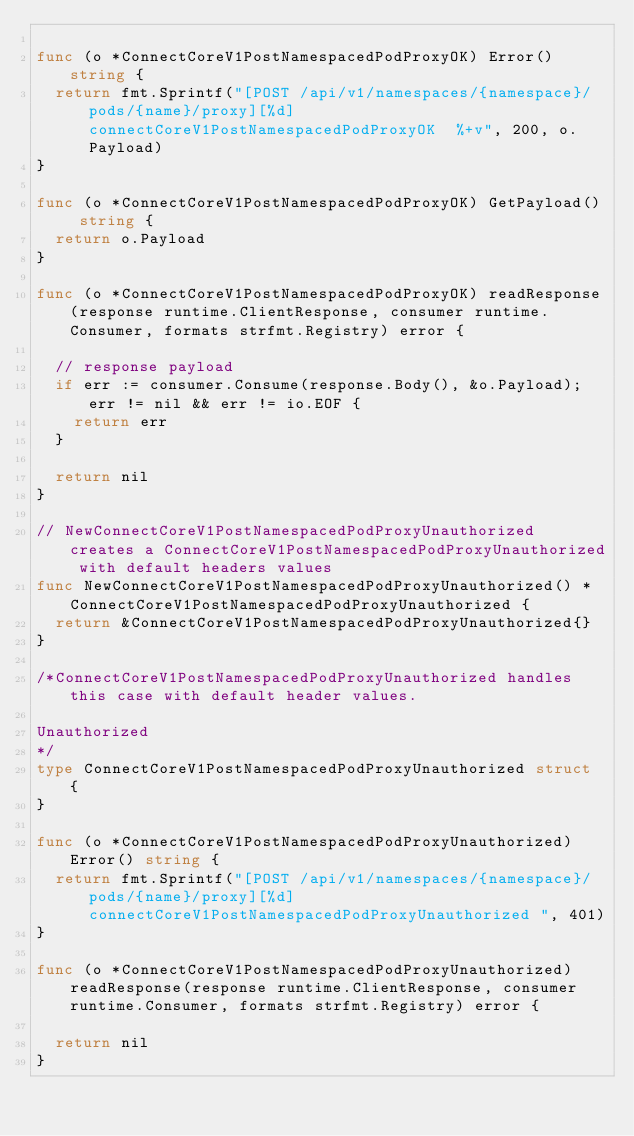<code> <loc_0><loc_0><loc_500><loc_500><_Go_>
func (o *ConnectCoreV1PostNamespacedPodProxyOK) Error() string {
	return fmt.Sprintf("[POST /api/v1/namespaces/{namespace}/pods/{name}/proxy][%d] connectCoreV1PostNamespacedPodProxyOK  %+v", 200, o.Payload)
}

func (o *ConnectCoreV1PostNamespacedPodProxyOK) GetPayload() string {
	return o.Payload
}

func (o *ConnectCoreV1PostNamespacedPodProxyOK) readResponse(response runtime.ClientResponse, consumer runtime.Consumer, formats strfmt.Registry) error {

	// response payload
	if err := consumer.Consume(response.Body(), &o.Payload); err != nil && err != io.EOF {
		return err
	}

	return nil
}

// NewConnectCoreV1PostNamespacedPodProxyUnauthorized creates a ConnectCoreV1PostNamespacedPodProxyUnauthorized with default headers values
func NewConnectCoreV1PostNamespacedPodProxyUnauthorized() *ConnectCoreV1PostNamespacedPodProxyUnauthorized {
	return &ConnectCoreV1PostNamespacedPodProxyUnauthorized{}
}

/*ConnectCoreV1PostNamespacedPodProxyUnauthorized handles this case with default header values.

Unauthorized
*/
type ConnectCoreV1PostNamespacedPodProxyUnauthorized struct {
}

func (o *ConnectCoreV1PostNamespacedPodProxyUnauthorized) Error() string {
	return fmt.Sprintf("[POST /api/v1/namespaces/{namespace}/pods/{name}/proxy][%d] connectCoreV1PostNamespacedPodProxyUnauthorized ", 401)
}

func (o *ConnectCoreV1PostNamespacedPodProxyUnauthorized) readResponse(response runtime.ClientResponse, consumer runtime.Consumer, formats strfmt.Registry) error {

	return nil
}
</code> 